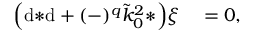Convert formula to latex. <formula><loc_0><loc_0><loc_500><loc_500>\begin{array} { r l } { \left ( d { * d } + ( - ) ^ { q } \tilde { k } _ { 0 } ^ { 2 } { * } \right ) \xi } & = 0 , } \end{array}</formula> 